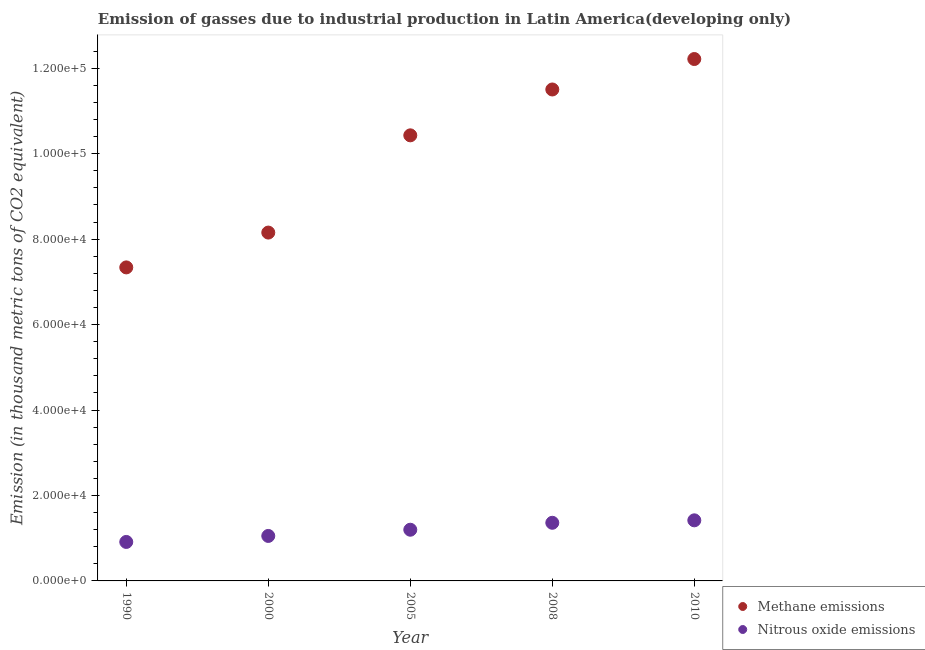What is the amount of methane emissions in 2000?
Provide a short and direct response. 8.15e+04. Across all years, what is the maximum amount of methane emissions?
Provide a short and direct response. 1.22e+05. Across all years, what is the minimum amount of methane emissions?
Give a very brief answer. 7.34e+04. In which year was the amount of nitrous oxide emissions minimum?
Offer a very short reply. 1990. What is the total amount of methane emissions in the graph?
Ensure brevity in your answer.  4.96e+05. What is the difference between the amount of methane emissions in 1990 and that in 2008?
Ensure brevity in your answer.  -4.16e+04. What is the difference between the amount of methane emissions in 2008 and the amount of nitrous oxide emissions in 2005?
Provide a short and direct response. 1.03e+05. What is the average amount of nitrous oxide emissions per year?
Offer a very short reply. 1.19e+04. In the year 1990, what is the difference between the amount of nitrous oxide emissions and amount of methane emissions?
Your response must be concise. -6.43e+04. What is the ratio of the amount of nitrous oxide emissions in 2000 to that in 2005?
Offer a very short reply. 0.88. Is the amount of methane emissions in 2005 less than that in 2010?
Your answer should be very brief. Yes. What is the difference between the highest and the second highest amount of nitrous oxide emissions?
Make the answer very short. 576.2. What is the difference between the highest and the lowest amount of nitrous oxide emissions?
Give a very brief answer. 5058. In how many years, is the amount of methane emissions greater than the average amount of methane emissions taken over all years?
Provide a short and direct response. 3. Is the sum of the amount of methane emissions in 1990 and 2000 greater than the maximum amount of nitrous oxide emissions across all years?
Provide a succinct answer. Yes. Is the amount of nitrous oxide emissions strictly less than the amount of methane emissions over the years?
Ensure brevity in your answer.  Yes. Are the values on the major ticks of Y-axis written in scientific E-notation?
Your answer should be very brief. Yes. Where does the legend appear in the graph?
Ensure brevity in your answer.  Bottom right. How many legend labels are there?
Keep it short and to the point. 2. How are the legend labels stacked?
Offer a terse response. Vertical. What is the title of the graph?
Provide a short and direct response. Emission of gasses due to industrial production in Latin America(developing only). Does "External balance on goods" appear as one of the legend labels in the graph?
Offer a terse response. No. What is the label or title of the Y-axis?
Offer a very short reply. Emission (in thousand metric tons of CO2 equivalent). What is the Emission (in thousand metric tons of CO2 equivalent) of Methane emissions in 1990?
Keep it short and to the point. 7.34e+04. What is the Emission (in thousand metric tons of CO2 equivalent) in Nitrous oxide emissions in 1990?
Your answer should be compact. 9123.8. What is the Emission (in thousand metric tons of CO2 equivalent) in Methane emissions in 2000?
Provide a short and direct response. 8.15e+04. What is the Emission (in thousand metric tons of CO2 equivalent) in Nitrous oxide emissions in 2000?
Give a very brief answer. 1.05e+04. What is the Emission (in thousand metric tons of CO2 equivalent) of Methane emissions in 2005?
Keep it short and to the point. 1.04e+05. What is the Emission (in thousand metric tons of CO2 equivalent) of Nitrous oxide emissions in 2005?
Make the answer very short. 1.20e+04. What is the Emission (in thousand metric tons of CO2 equivalent) of Methane emissions in 2008?
Your answer should be very brief. 1.15e+05. What is the Emission (in thousand metric tons of CO2 equivalent) in Nitrous oxide emissions in 2008?
Your response must be concise. 1.36e+04. What is the Emission (in thousand metric tons of CO2 equivalent) of Methane emissions in 2010?
Provide a short and direct response. 1.22e+05. What is the Emission (in thousand metric tons of CO2 equivalent) of Nitrous oxide emissions in 2010?
Your answer should be compact. 1.42e+04. Across all years, what is the maximum Emission (in thousand metric tons of CO2 equivalent) in Methane emissions?
Make the answer very short. 1.22e+05. Across all years, what is the maximum Emission (in thousand metric tons of CO2 equivalent) in Nitrous oxide emissions?
Offer a very short reply. 1.42e+04. Across all years, what is the minimum Emission (in thousand metric tons of CO2 equivalent) in Methane emissions?
Ensure brevity in your answer.  7.34e+04. Across all years, what is the minimum Emission (in thousand metric tons of CO2 equivalent) in Nitrous oxide emissions?
Offer a terse response. 9123.8. What is the total Emission (in thousand metric tons of CO2 equivalent) in Methane emissions in the graph?
Ensure brevity in your answer.  4.96e+05. What is the total Emission (in thousand metric tons of CO2 equivalent) of Nitrous oxide emissions in the graph?
Provide a short and direct response. 5.94e+04. What is the difference between the Emission (in thousand metric tons of CO2 equivalent) of Methane emissions in 1990 and that in 2000?
Offer a very short reply. -8151.9. What is the difference between the Emission (in thousand metric tons of CO2 equivalent) in Nitrous oxide emissions in 1990 and that in 2000?
Keep it short and to the point. -1404.8. What is the difference between the Emission (in thousand metric tons of CO2 equivalent) of Methane emissions in 1990 and that in 2005?
Offer a terse response. -3.09e+04. What is the difference between the Emission (in thousand metric tons of CO2 equivalent) in Nitrous oxide emissions in 1990 and that in 2005?
Offer a terse response. -2858. What is the difference between the Emission (in thousand metric tons of CO2 equivalent) in Methane emissions in 1990 and that in 2008?
Provide a succinct answer. -4.16e+04. What is the difference between the Emission (in thousand metric tons of CO2 equivalent) in Nitrous oxide emissions in 1990 and that in 2008?
Ensure brevity in your answer.  -4481.8. What is the difference between the Emission (in thousand metric tons of CO2 equivalent) in Methane emissions in 1990 and that in 2010?
Ensure brevity in your answer.  -4.88e+04. What is the difference between the Emission (in thousand metric tons of CO2 equivalent) of Nitrous oxide emissions in 1990 and that in 2010?
Your response must be concise. -5058. What is the difference between the Emission (in thousand metric tons of CO2 equivalent) in Methane emissions in 2000 and that in 2005?
Offer a terse response. -2.28e+04. What is the difference between the Emission (in thousand metric tons of CO2 equivalent) of Nitrous oxide emissions in 2000 and that in 2005?
Your answer should be very brief. -1453.2. What is the difference between the Emission (in thousand metric tons of CO2 equivalent) in Methane emissions in 2000 and that in 2008?
Provide a succinct answer. -3.35e+04. What is the difference between the Emission (in thousand metric tons of CO2 equivalent) of Nitrous oxide emissions in 2000 and that in 2008?
Provide a succinct answer. -3077. What is the difference between the Emission (in thousand metric tons of CO2 equivalent) of Methane emissions in 2000 and that in 2010?
Ensure brevity in your answer.  -4.06e+04. What is the difference between the Emission (in thousand metric tons of CO2 equivalent) in Nitrous oxide emissions in 2000 and that in 2010?
Offer a very short reply. -3653.2. What is the difference between the Emission (in thousand metric tons of CO2 equivalent) in Methane emissions in 2005 and that in 2008?
Your response must be concise. -1.07e+04. What is the difference between the Emission (in thousand metric tons of CO2 equivalent) in Nitrous oxide emissions in 2005 and that in 2008?
Give a very brief answer. -1623.8. What is the difference between the Emission (in thousand metric tons of CO2 equivalent) in Methane emissions in 2005 and that in 2010?
Offer a terse response. -1.79e+04. What is the difference between the Emission (in thousand metric tons of CO2 equivalent) in Nitrous oxide emissions in 2005 and that in 2010?
Ensure brevity in your answer.  -2200. What is the difference between the Emission (in thousand metric tons of CO2 equivalent) in Methane emissions in 2008 and that in 2010?
Keep it short and to the point. -7129.8. What is the difference between the Emission (in thousand metric tons of CO2 equivalent) of Nitrous oxide emissions in 2008 and that in 2010?
Ensure brevity in your answer.  -576.2. What is the difference between the Emission (in thousand metric tons of CO2 equivalent) of Methane emissions in 1990 and the Emission (in thousand metric tons of CO2 equivalent) of Nitrous oxide emissions in 2000?
Provide a short and direct response. 6.29e+04. What is the difference between the Emission (in thousand metric tons of CO2 equivalent) in Methane emissions in 1990 and the Emission (in thousand metric tons of CO2 equivalent) in Nitrous oxide emissions in 2005?
Make the answer very short. 6.14e+04. What is the difference between the Emission (in thousand metric tons of CO2 equivalent) of Methane emissions in 1990 and the Emission (in thousand metric tons of CO2 equivalent) of Nitrous oxide emissions in 2008?
Offer a terse response. 5.98e+04. What is the difference between the Emission (in thousand metric tons of CO2 equivalent) in Methane emissions in 1990 and the Emission (in thousand metric tons of CO2 equivalent) in Nitrous oxide emissions in 2010?
Provide a short and direct response. 5.92e+04. What is the difference between the Emission (in thousand metric tons of CO2 equivalent) in Methane emissions in 2000 and the Emission (in thousand metric tons of CO2 equivalent) in Nitrous oxide emissions in 2005?
Provide a succinct answer. 6.96e+04. What is the difference between the Emission (in thousand metric tons of CO2 equivalent) in Methane emissions in 2000 and the Emission (in thousand metric tons of CO2 equivalent) in Nitrous oxide emissions in 2008?
Provide a succinct answer. 6.79e+04. What is the difference between the Emission (in thousand metric tons of CO2 equivalent) in Methane emissions in 2000 and the Emission (in thousand metric tons of CO2 equivalent) in Nitrous oxide emissions in 2010?
Offer a very short reply. 6.74e+04. What is the difference between the Emission (in thousand metric tons of CO2 equivalent) of Methane emissions in 2005 and the Emission (in thousand metric tons of CO2 equivalent) of Nitrous oxide emissions in 2008?
Give a very brief answer. 9.07e+04. What is the difference between the Emission (in thousand metric tons of CO2 equivalent) in Methane emissions in 2005 and the Emission (in thousand metric tons of CO2 equivalent) in Nitrous oxide emissions in 2010?
Offer a terse response. 9.01e+04. What is the difference between the Emission (in thousand metric tons of CO2 equivalent) of Methane emissions in 2008 and the Emission (in thousand metric tons of CO2 equivalent) of Nitrous oxide emissions in 2010?
Offer a terse response. 1.01e+05. What is the average Emission (in thousand metric tons of CO2 equivalent) in Methane emissions per year?
Your response must be concise. 9.93e+04. What is the average Emission (in thousand metric tons of CO2 equivalent) of Nitrous oxide emissions per year?
Make the answer very short. 1.19e+04. In the year 1990, what is the difference between the Emission (in thousand metric tons of CO2 equivalent) in Methane emissions and Emission (in thousand metric tons of CO2 equivalent) in Nitrous oxide emissions?
Your response must be concise. 6.43e+04. In the year 2000, what is the difference between the Emission (in thousand metric tons of CO2 equivalent) in Methane emissions and Emission (in thousand metric tons of CO2 equivalent) in Nitrous oxide emissions?
Ensure brevity in your answer.  7.10e+04. In the year 2005, what is the difference between the Emission (in thousand metric tons of CO2 equivalent) in Methane emissions and Emission (in thousand metric tons of CO2 equivalent) in Nitrous oxide emissions?
Offer a terse response. 9.23e+04. In the year 2008, what is the difference between the Emission (in thousand metric tons of CO2 equivalent) in Methane emissions and Emission (in thousand metric tons of CO2 equivalent) in Nitrous oxide emissions?
Ensure brevity in your answer.  1.01e+05. In the year 2010, what is the difference between the Emission (in thousand metric tons of CO2 equivalent) of Methane emissions and Emission (in thousand metric tons of CO2 equivalent) of Nitrous oxide emissions?
Make the answer very short. 1.08e+05. What is the ratio of the Emission (in thousand metric tons of CO2 equivalent) in Nitrous oxide emissions in 1990 to that in 2000?
Your response must be concise. 0.87. What is the ratio of the Emission (in thousand metric tons of CO2 equivalent) of Methane emissions in 1990 to that in 2005?
Offer a terse response. 0.7. What is the ratio of the Emission (in thousand metric tons of CO2 equivalent) of Nitrous oxide emissions in 1990 to that in 2005?
Your response must be concise. 0.76. What is the ratio of the Emission (in thousand metric tons of CO2 equivalent) of Methane emissions in 1990 to that in 2008?
Your answer should be very brief. 0.64. What is the ratio of the Emission (in thousand metric tons of CO2 equivalent) of Nitrous oxide emissions in 1990 to that in 2008?
Make the answer very short. 0.67. What is the ratio of the Emission (in thousand metric tons of CO2 equivalent) in Methane emissions in 1990 to that in 2010?
Offer a terse response. 0.6. What is the ratio of the Emission (in thousand metric tons of CO2 equivalent) of Nitrous oxide emissions in 1990 to that in 2010?
Keep it short and to the point. 0.64. What is the ratio of the Emission (in thousand metric tons of CO2 equivalent) of Methane emissions in 2000 to that in 2005?
Provide a succinct answer. 0.78. What is the ratio of the Emission (in thousand metric tons of CO2 equivalent) of Nitrous oxide emissions in 2000 to that in 2005?
Provide a succinct answer. 0.88. What is the ratio of the Emission (in thousand metric tons of CO2 equivalent) of Methane emissions in 2000 to that in 2008?
Keep it short and to the point. 0.71. What is the ratio of the Emission (in thousand metric tons of CO2 equivalent) in Nitrous oxide emissions in 2000 to that in 2008?
Provide a succinct answer. 0.77. What is the ratio of the Emission (in thousand metric tons of CO2 equivalent) of Methane emissions in 2000 to that in 2010?
Your answer should be very brief. 0.67. What is the ratio of the Emission (in thousand metric tons of CO2 equivalent) in Nitrous oxide emissions in 2000 to that in 2010?
Keep it short and to the point. 0.74. What is the ratio of the Emission (in thousand metric tons of CO2 equivalent) in Methane emissions in 2005 to that in 2008?
Provide a succinct answer. 0.91. What is the ratio of the Emission (in thousand metric tons of CO2 equivalent) in Nitrous oxide emissions in 2005 to that in 2008?
Your response must be concise. 0.88. What is the ratio of the Emission (in thousand metric tons of CO2 equivalent) of Methane emissions in 2005 to that in 2010?
Keep it short and to the point. 0.85. What is the ratio of the Emission (in thousand metric tons of CO2 equivalent) of Nitrous oxide emissions in 2005 to that in 2010?
Provide a short and direct response. 0.84. What is the ratio of the Emission (in thousand metric tons of CO2 equivalent) of Methane emissions in 2008 to that in 2010?
Offer a very short reply. 0.94. What is the ratio of the Emission (in thousand metric tons of CO2 equivalent) of Nitrous oxide emissions in 2008 to that in 2010?
Make the answer very short. 0.96. What is the difference between the highest and the second highest Emission (in thousand metric tons of CO2 equivalent) in Methane emissions?
Give a very brief answer. 7129.8. What is the difference between the highest and the second highest Emission (in thousand metric tons of CO2 equivalent) of Nitrous oxide emissions?
Keep it short and to the point. 576.2. What is the difference between the highest and the lowest Emission (in thousand metric tons of CO2 equivalent) of Methane emissions?
Ensure brevity in your answer.  4.88e+04. What is the difference between the highest and the lowest Emission (in thousand metric tons of CO2 equivalent) in Nitrous oxide emissions?
Provide a succinct answer. 5058. 